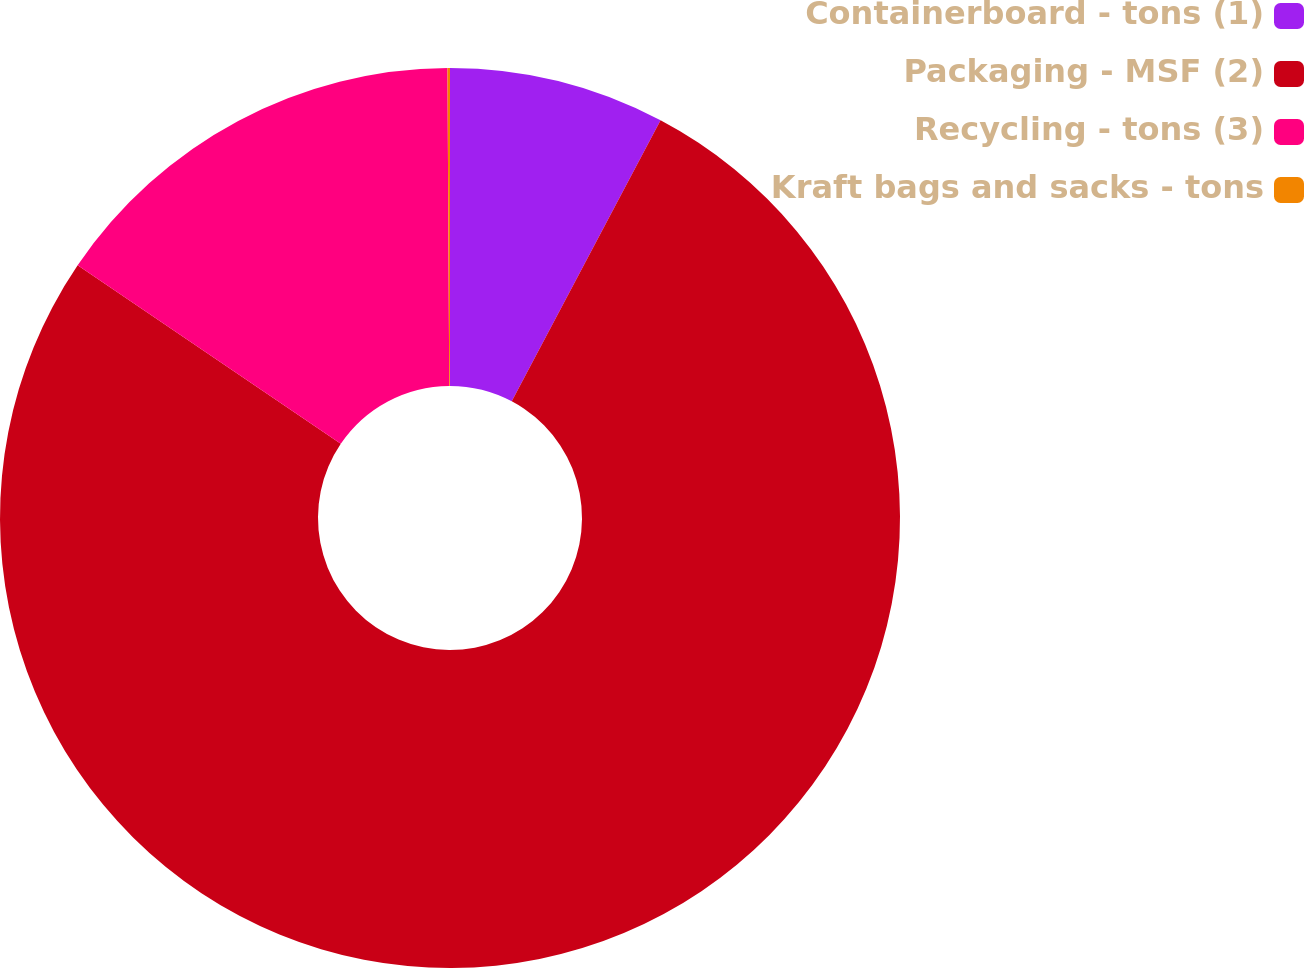<chart> <loc_0><loc_0><loc_500><loc_500><pie_chart><fcel>Containerboard - tons (1)<fcel>Packaging - MSF (2)<fcel>Recycling - tons (3)<fcel>Kraft bags and sacks - tons<nl><fcel>7.75%<fcel>76.74%<fcel>15.42%<fcel>0.09%<nl></chart> 